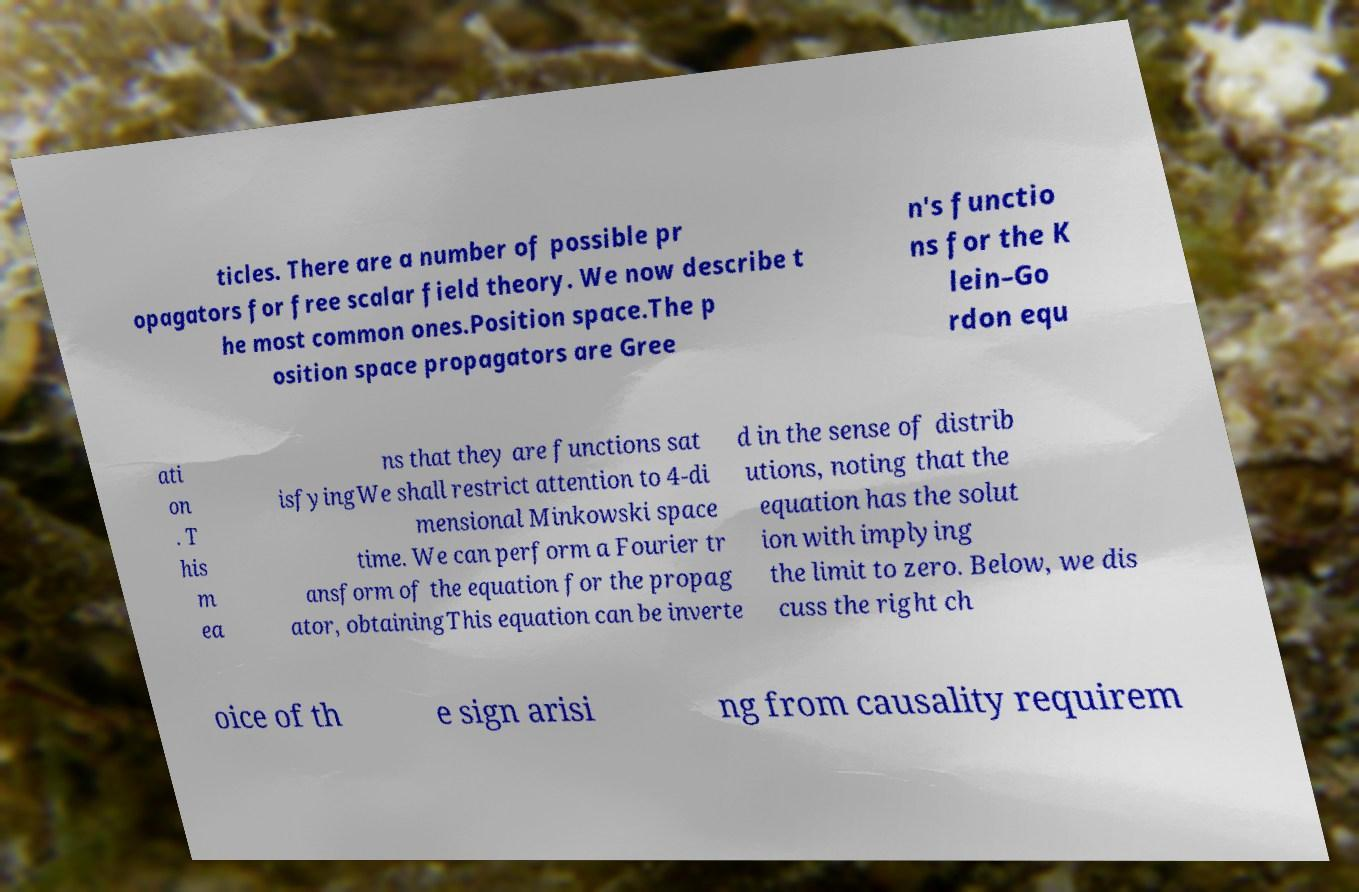Please identify and transcribe the text found in this image. ticles. There are a number of possible pr opagators for free scalar field theory. We now describe t he most common ones.Position space.The p osition space propagators are Gree n's functio ns for the K lein–Go rdon equ ati on . T his m ea ns that they are functions sat isfyingWe shall restrict attention to 4-di mensional Minkowski space time. We can perform a Fourier tr ansform of the equation for the propag ator, obtainingThis equation can be inverte d in the sense of distrib utions, noting that the equation has the solut ion with implying the limit to zero. Below, we dis cuss the right ch oice of th e sign arisi ng from causality requirem 